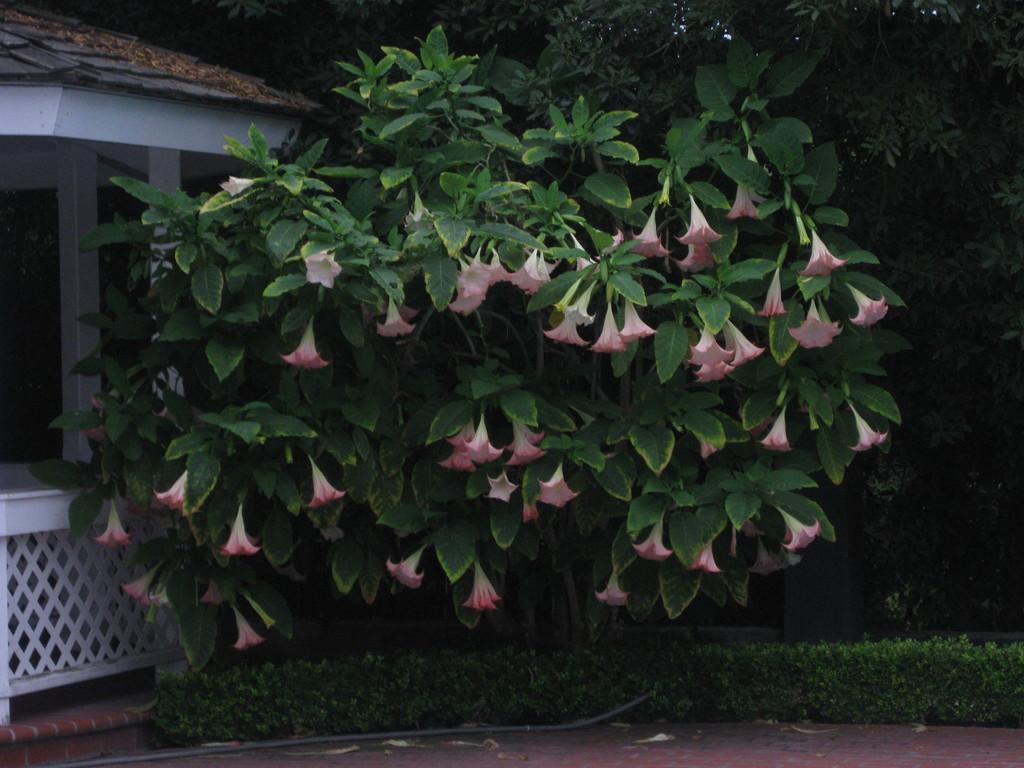Could you give a brief overview of what you see in this image? In the foreground of this picture, there are flowers to the plant. On the bottom side there are plants. On the left, there is a shed. In the background, there are trees. 